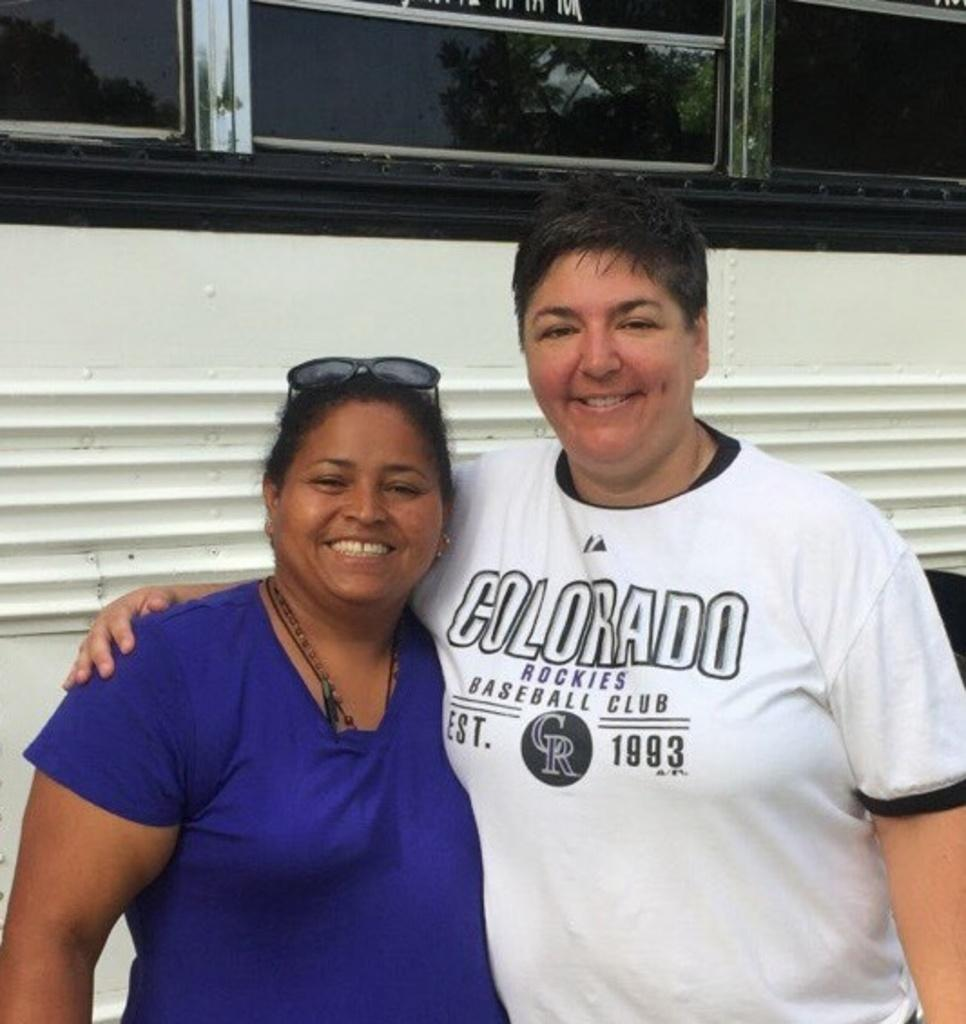How many people are present in the image? There are two persons in the image. What is located behind the persons? There is a wall visible behind the persons. What object is at the top of the image? There is a glass at the top of the image. What can be seen reflected on the glass? The reflection of trees and the sky is visible on the glass. What type of cabbage is being used as a hat by one of the persons in the image? There is no cabbage present in the image, nor is any person wearing a cabbage as a hat. 